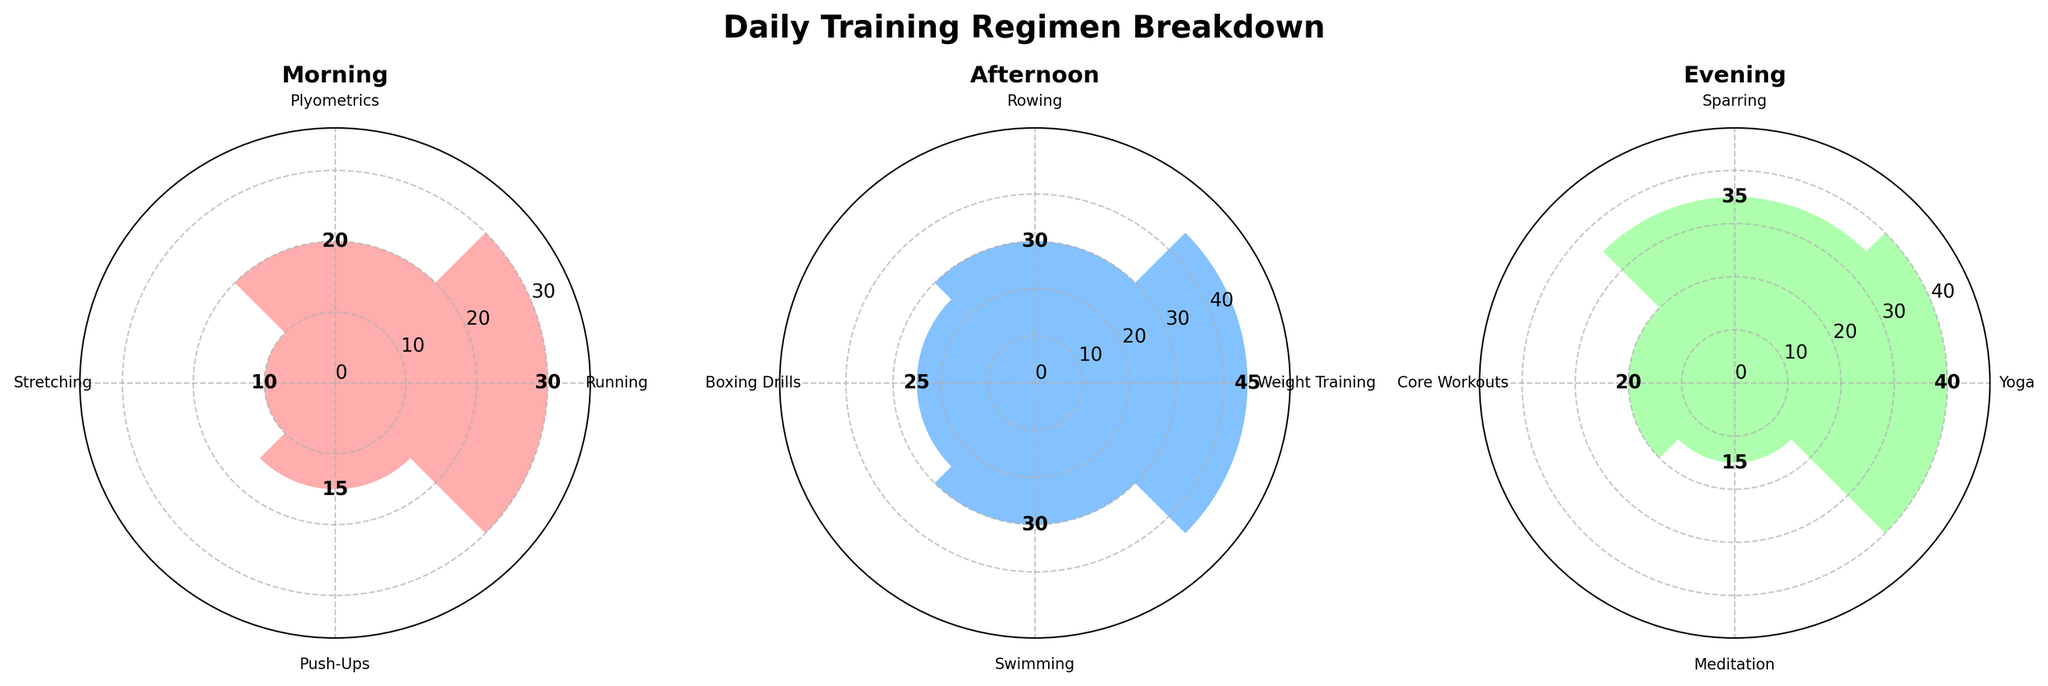What is the title of the figure? The title appears at the top of the figure in bold, stating the overall subject of the figure.
Answer: Daily Training Regimen Breakdown Which period has the longest single activity duration? Look for the highest bar among all subplots representing different periods: Morning, Afternoon, and Evening.
Answer: Afternoon What activities are visualized in the Morning period? Look at the labels around the top rim of the first subplot (Morning) to identify the activities listed.
Answer: Running, Plyometrics, Stretching, Push-Ups Compare the total duration of activities between the Morning and Evening periods. Which has more? Sum the durations of activities in the Morning and Evening periods and compare them. Morning: 30+20+10+15 = 75 minutes. Evening: 40+35+20+15 = 110 minutes.
Answer: Evening Which activity in the Evening period has the shortest duration? Check the lengths of the bars in the Evening subplot to identify the shortest one.
Answer: Meditation What is the average duration of activities in the Afternoon period? Sum the durations of the activities in the Afternoon and divide by the number of activities. (45+30+25+30) / 4 = 32.5 minutes.
Answer: 32.5 minutes How many different activities are charted in total? Count the total number of unique activity labels across all three periods. There are 12 individual activity names.
Answer: 12 Which period has the most diverse training regimen in terms of different activities? Compare the number of unique activities in each period by counting the labels: Morning 4, Afternoon 4, Evening 4.
Answer: All periods have an equal number of activities Is there any activity that appears more than once across different periods? Review the activities in each subplot and cross-check if any names repeat.
Answer: No 